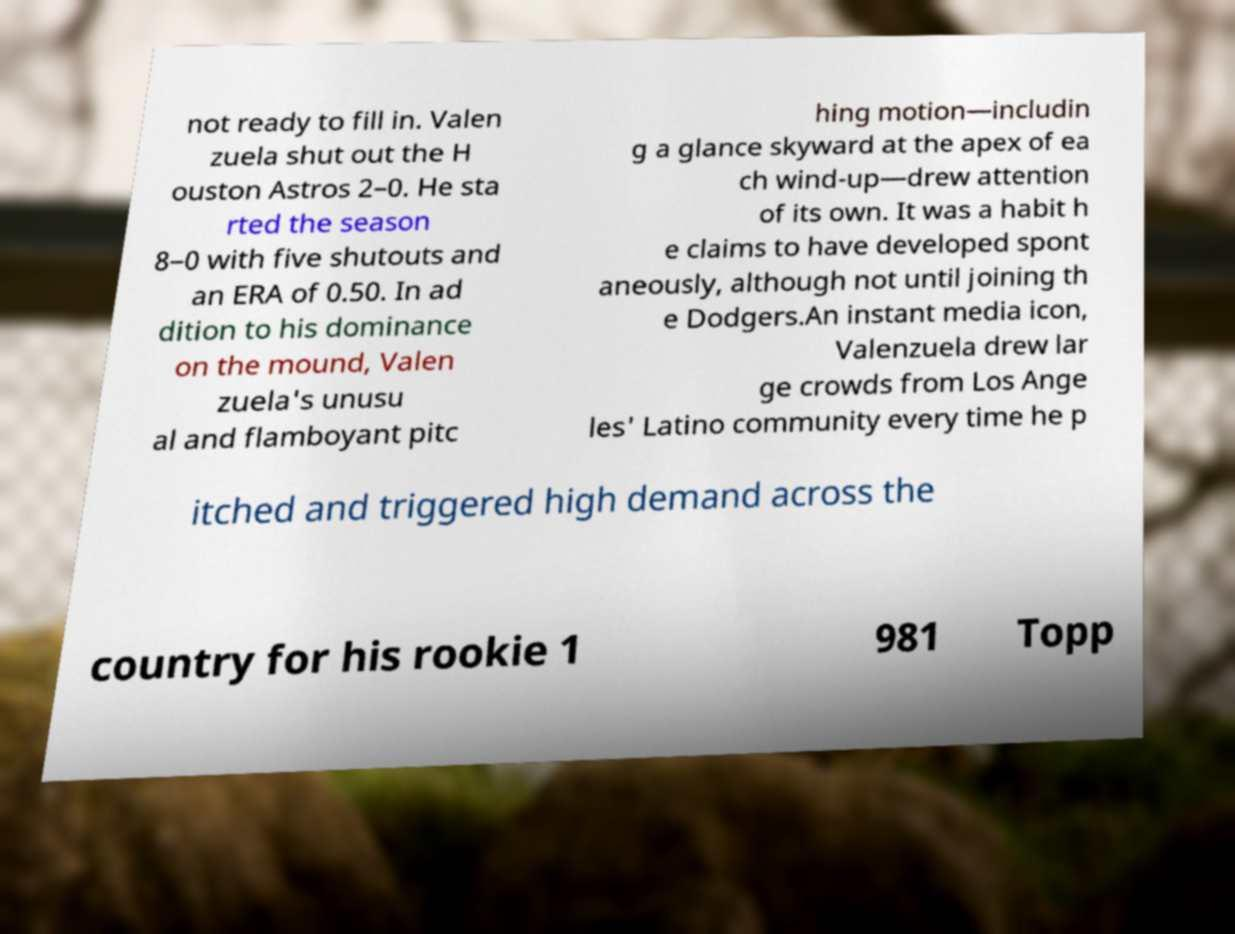Please read and relay the text visible in this image. What does it say? not ready to fill in. Valen zuela shut out the H ouston Astros 2–0. He sta rted the season 8–0 with five shutouts and an ERA of 0.50. In ad dition to his dominance on the mound, Valen zuela's unusu al and flamboyant pitc hing motion—includin g a glance skyward at the apex of ea ch wind-up—drew attention of its own. It was a habit h e claims to have developed spont aneously, although not until joining th e Dodgers.An instant media icon, Valenzuela drew lar ge crowds from Los Ange les' Latino community every time he p itched and triggered high demand across the country for his rookie 1 981 Topp 